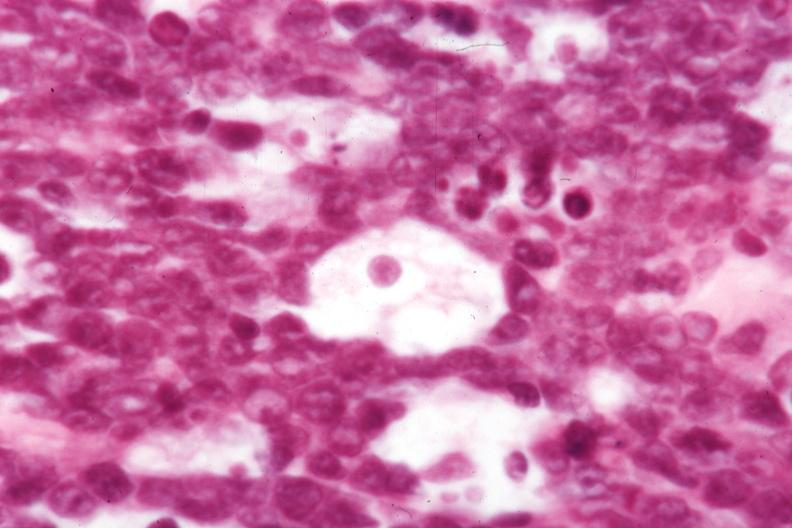what is typical for dx?
Answer the question using a single word or phrase. Morphology 